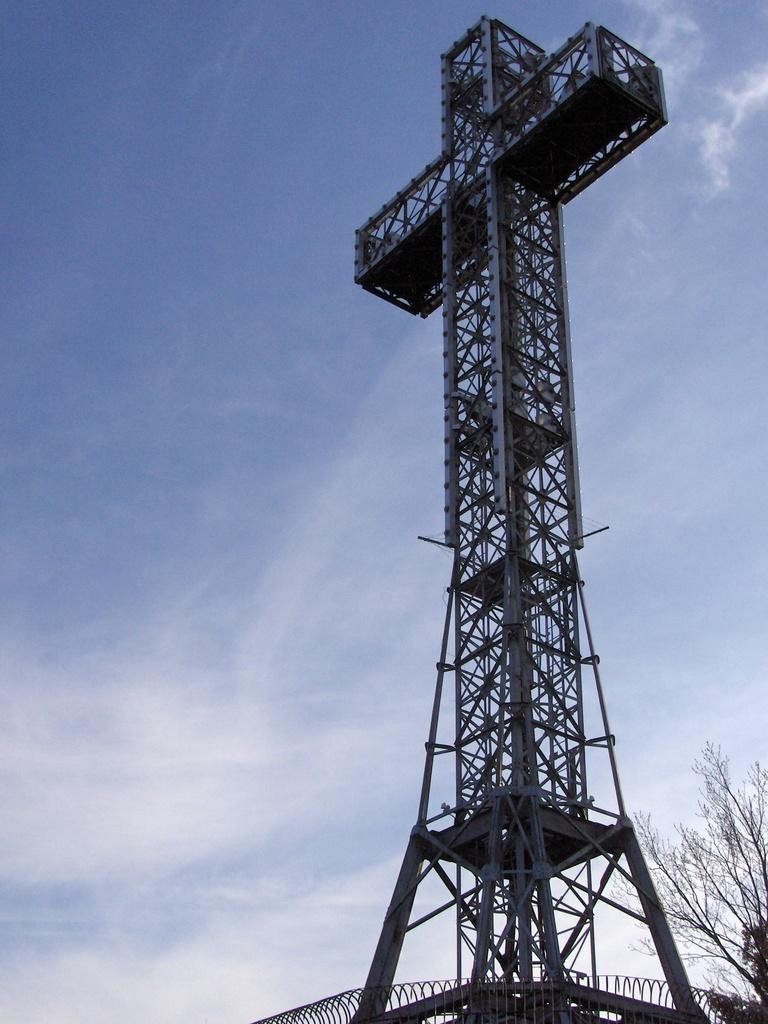What is the main structure in the image? There is a tower in the image. What type of vegetation is on the right side of the image? There is a tree on the right side of the image. What can be seen in the background of the image? The sky is visible in the background of the image. What type of writing can be seen on the tree in the image? There is no writing present on the tree in the image. Is there a tiger visible in the image? No, there is no tiger present in the image. 